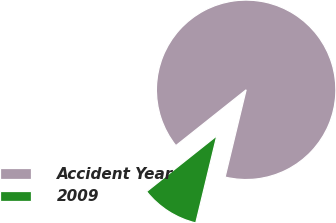Convert chart. <chart><loc_0><loc_0><loc_500><loc_500><pie_chart><fcel>Accident Year<fcel>2009<nl><fcel>89.46%<fcel>10.54%<nl></chart> 